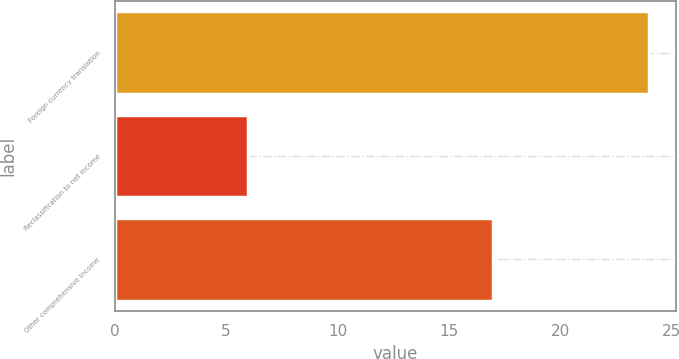Convert chart to OTSL. <chart><loc_0><loc_0><loc_500><loc_500><bar_chart><fcel>Foreign currency translation<fcel>Reclassification to net income<fcel>Other comprehensive income<nl><fcel>24<fcel>6<fcel>17<nl></chart> 